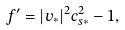<formula> <loc_0><loc_0><loc_500><loc_500>f ^ { \prime } = | { v } _ { \ast } | ^ { 2 } c _ { s \ast } ^ { 2 } - 1 ,</formula> 